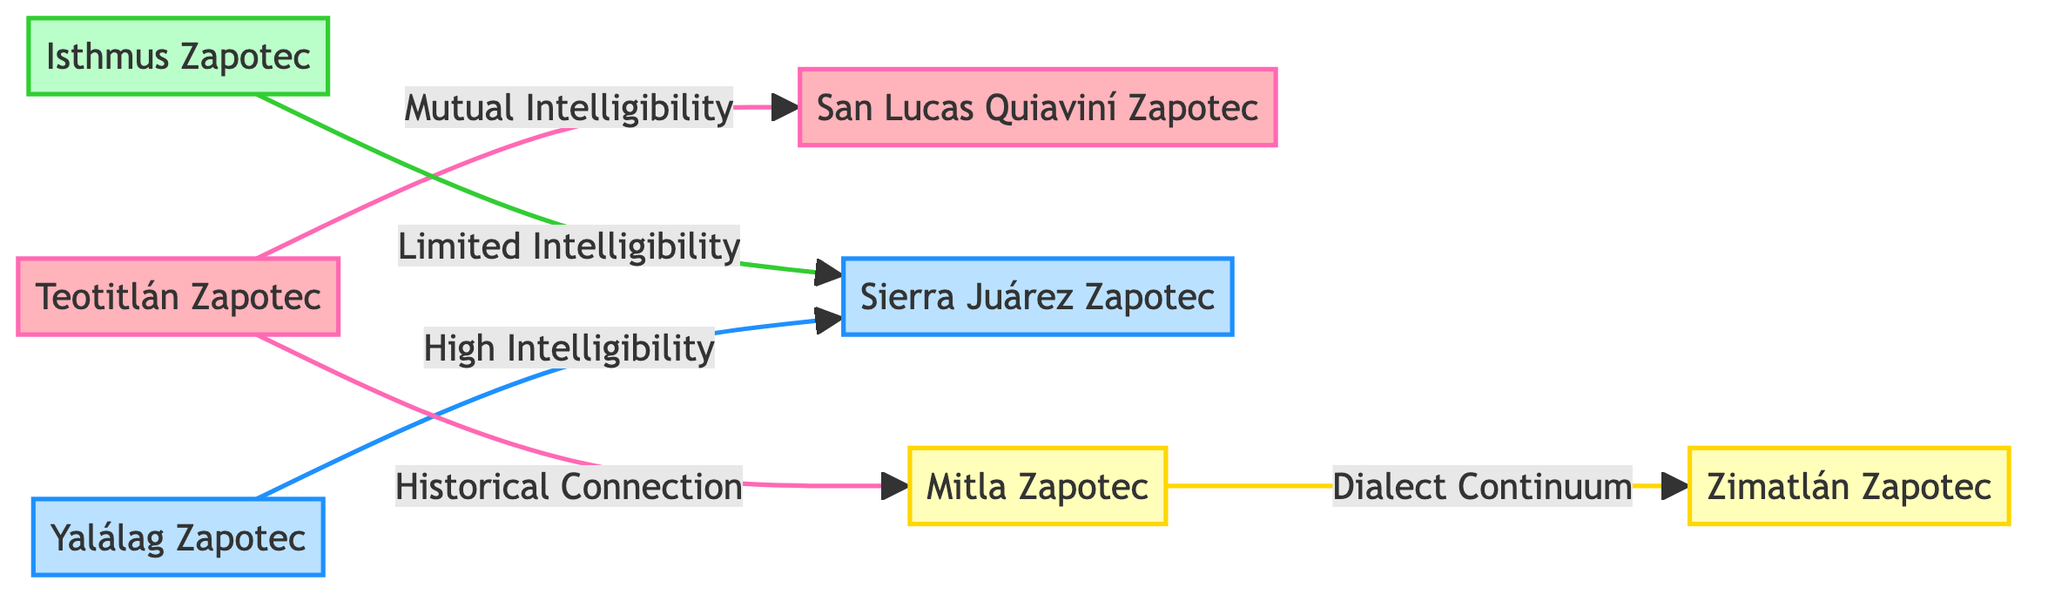What is the total number of nodes in the diagram? The diagram shows a total of 7 nodes representing different variants of Zapotec languages.
Answer: 7 Which languages are indicated to have mutual intelligibility? The diagram shows a connection labeled "Mutual Intelligibility" between Teotitlán Zapotec and San Lucas Quiaviní Zapotec.
Answer: Teotitlán Zapotec and San Lucas Quiaviní Zapotec What type of relationship exists between Mitla Zapotec and Zimatlán Zapotec? The diagram indicates a connection labeled "Dialect Continuum" between Mitla Zapotec and Zimatlán Zapotec, suggesting they share dialectical features across the continuum.
Answer: Dialect Continuum Which groups do the Sierra Juárez Zapotec belong to? The Sierra Juárez Zapotec is classified under the "Northern Zapotec" group as indicated in the node specifications within the diagram.
Answer: Northern Zapotec How many edges are represented in the diagram? The diagram contains 5 edges that represent various relationships among the nodes.
Answer: 5 What is the relationship between Isthmus Zapotec and Sierra Juárez Zapotec? The diagram shows a "Limited Intelligibility" connection between Isthmus Zapotec and Sierra Juárez Zapotec, indicating their mutual understanding is restricted.
Answer: Limited Intelligibility Identify the historical connection shown in the diagram. The diagram demonstrates a "Historical Connection" between Teotitlán Zapotec and Mitla Zapotec, indicating a historical link or influence between these two dialects.
Answer: Historical Connection Which Zapotec language variant is shown having high intelligibility with Sierra Juárez Zapotec? The diagram indicates that Yalálag Zapotec has a "High Intelligibility" relationship with Sierra Juárez Zapotec, suggesting close understanding between the speakers of these dialects.
Answer: Yalálag Zapotec What color represents the nodes belonging to the Valley Zapotec group? In the diagram, the nodes in the Valley Zapotec group are represented with a yellow fill color, as per the class definition provided.
Answer: Yellow 